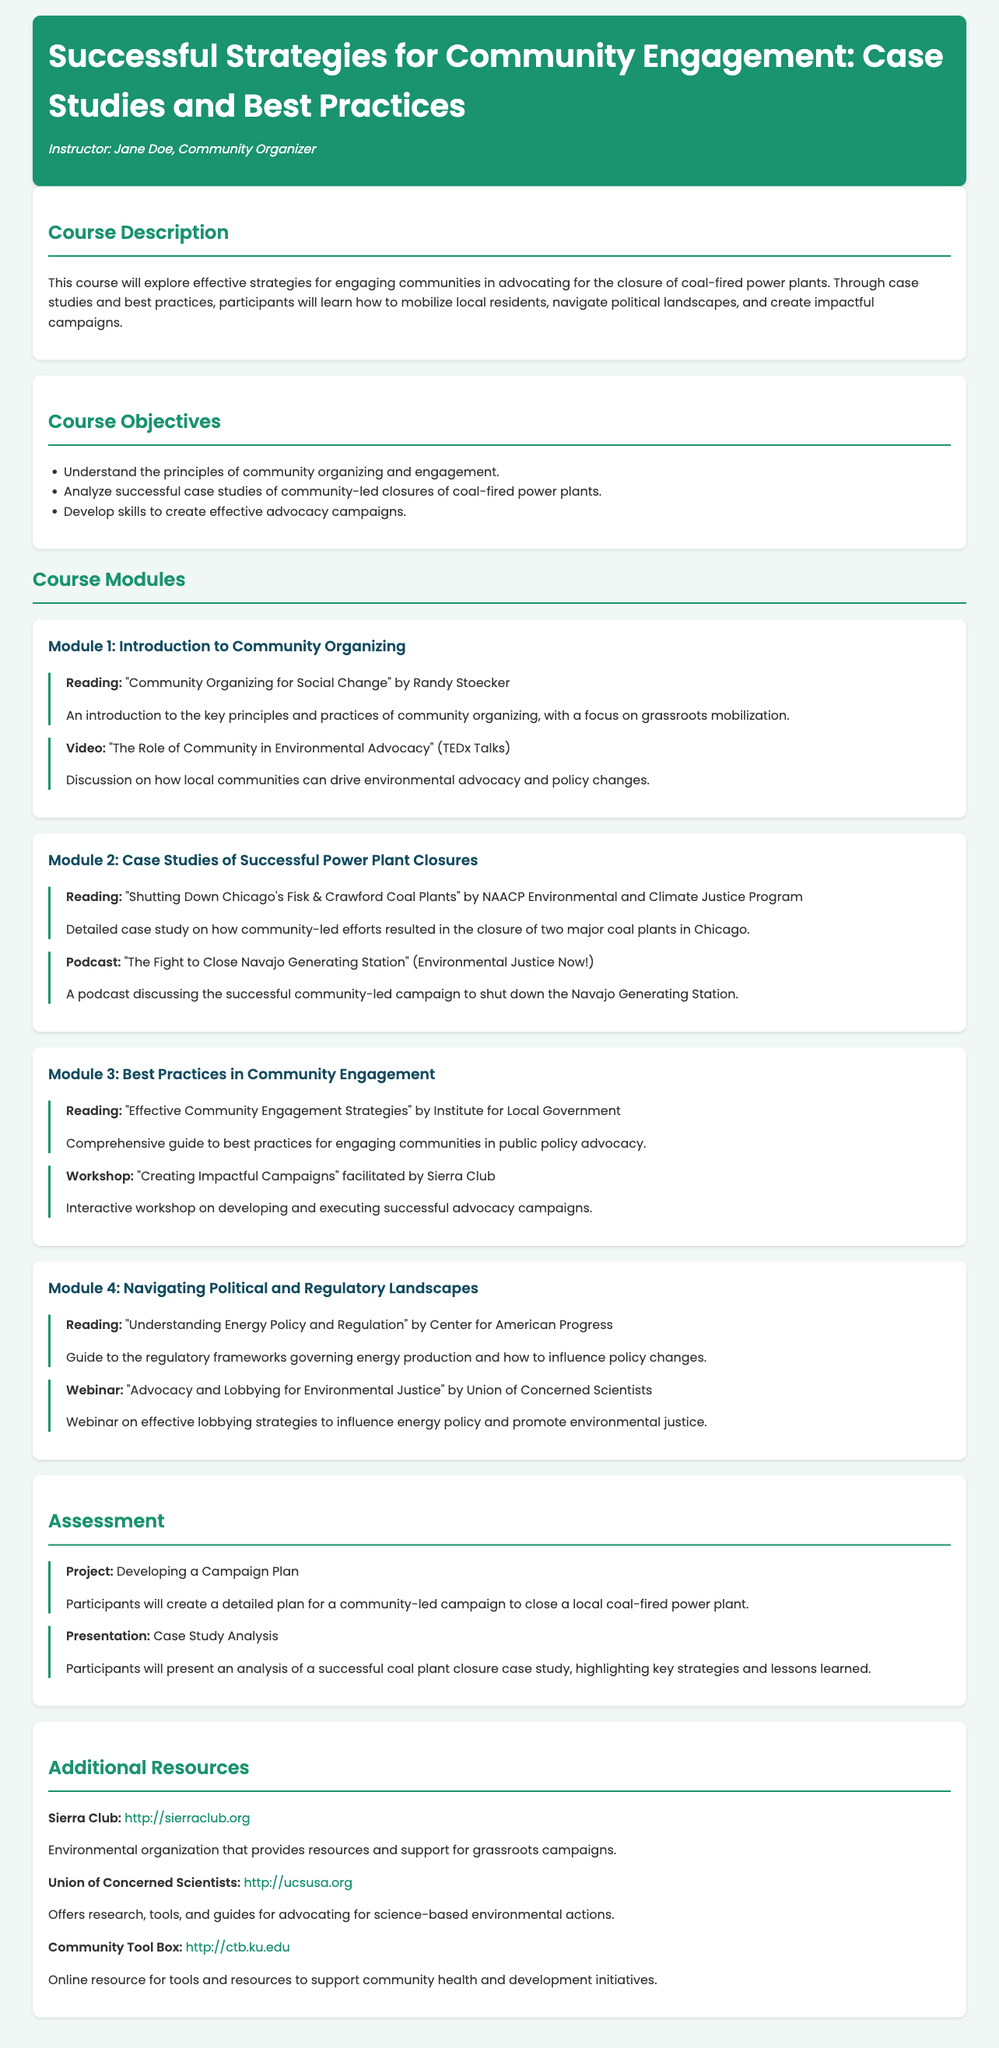What is the course title? The course title is prominently displayed at the top of the document.
Answer: Successful Strategies for Community Engagement: Case Studies and Best Practices Who is the instructor? The instructor's name is listed directly under the course title.
Answer: Jane Doe What is the first module about? The title of the first module is clearly stated in the document.
Answer: Introduction to Community Organizing What resource is listed for Module 2? A specific reading resource is mentioned in the context of the second module focused on case studies.
Answer: Shutting Down Chicago's Fisk & Crawford Coal Plants In which module is the workshop on impactful campaigns? The document identifies the module in which the workshop takes place.
Answer: Module 3 How many course objectives are outlined in the document? The total number of objectives can be counted from the list provided.
Answer: Three What type of project is included in the assessment? The nature of the project in the assessment section is explicitly stated.
Answer: Developing a Campaign Plan What organization is mentioned as a resource for grassroots campaigns? The document provides the name of a relevant organization under additional resources.
Answer: Sierra Club What format is the resource titled "Understanding Energy Policy and Regulation"? The type of content for this resource is specified in the module.
Answer: Reading 